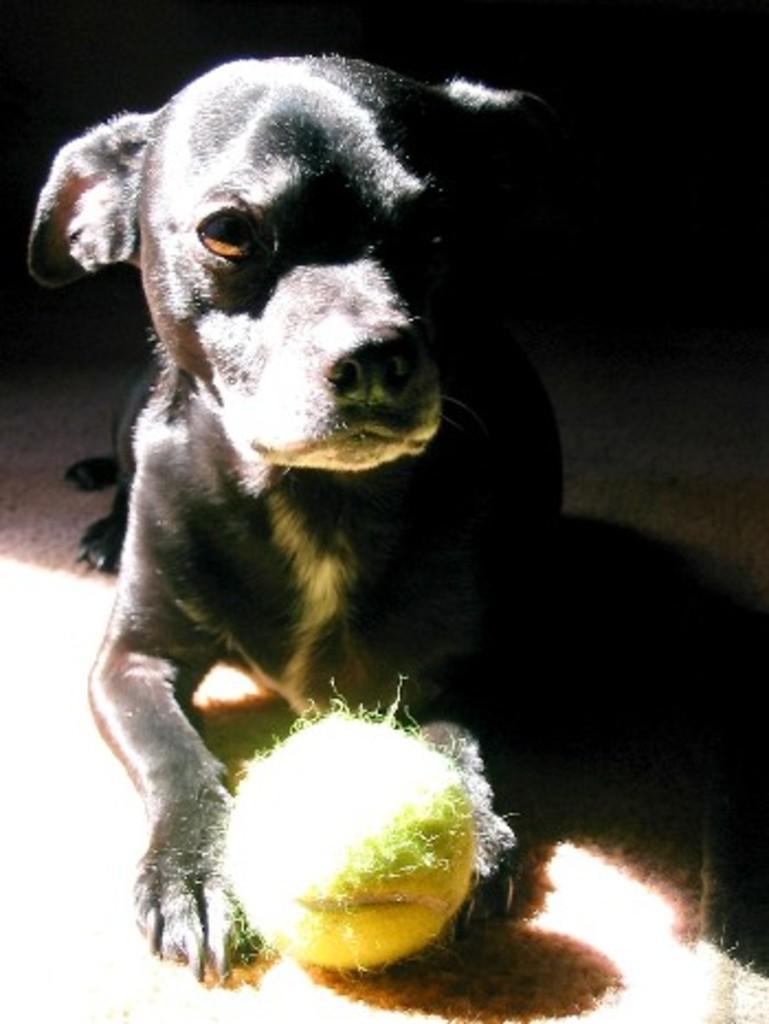Can you describe this image briefly? In this image we can see a dog with a ball. In the back it is dark. 